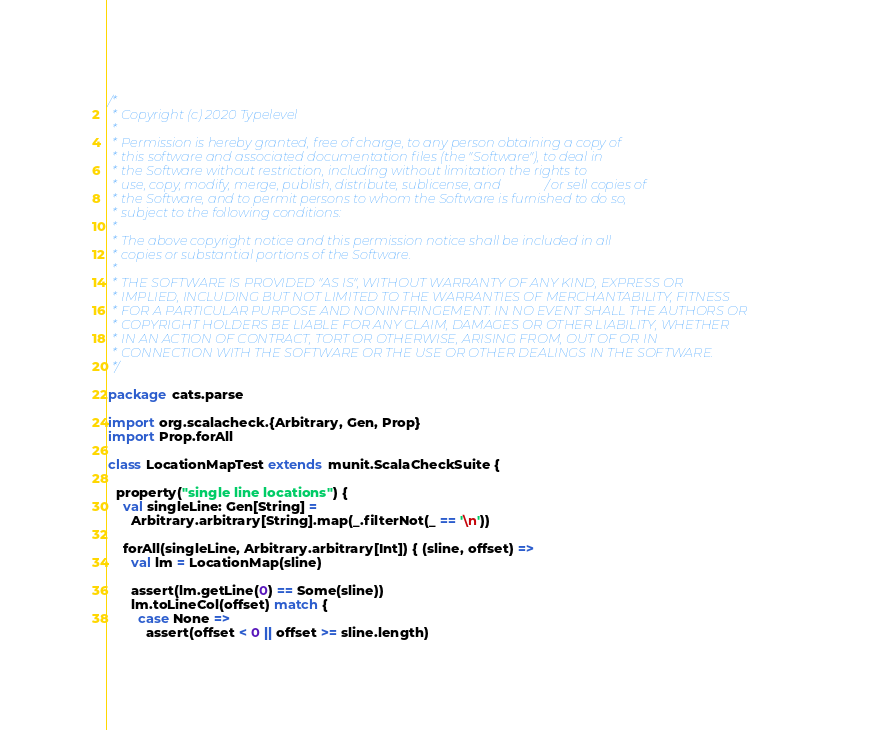<code> <loc_0><loc_0><loc_500><loc_500><_Scala_>/*
 * Copyright (c) 2020 Typelevel
 *
 * Permission is hereby granted, free of charge, to any person obtaining a copy of
 * this software and associated documentation files (the "Software"), to deal in
 * the Software without restriction, including without limitation the rights to
 * use, copy, modify, merge, publish, distribute, sublicense, and/or sell copies of
 * the Software, and to permit persons to whom the Software is furnished to do so,
 * subject to the following conditions:
 *
 * The above copyright notice and this permission notice shall be included in all
 * copies or substantial portions of the Software.
 *
 * THE SOFTWARE IS PROVIDED "AS IS", WITHOUT WARRANTY OF ANY KIND, EXPRESS OR
 * IMPLIED, INCLUDING BUT NOT LIMITED TO THE WARRANTIES OF MERCHANTABILITY, FITNESS
 * FOR A PARTICULAR PURPOSE AND NONINFRINGEMENT. IN NO EVENT SHALL THE AUTHORS OR
 * COPYRIGHT HOLDERS BE LIABLE FOR ANY CLAIM, DAMAGES OR OTHER LIABILITY, WHETHER
 * IN AN ACTION OF CONTRACT, TORT OR OTHERWISE, ARISING FROM, OUT OF OR IN
 * CONNECTION WITH THE SOFTWARE OR THE USE OR OTHER DEALINGS IN THE SOFTWARE.
 */

package cats.parse

import org.scalacheck.{Arbitrary, Gen, Prop}
import Prop.forAll

class LocationMapTest extends munit.ScalaCheckSuite {

  property("single line locations") {
    val singleLine: Gen[String] =
      Arbitrary.arbitrary[String].map(_.filterNot(_ == '\n'))

    forAll(singleLine, Arbitrary.arbitrary[Int]) { (sline, offset) =>
      val lm = LocationMap(sline)

      assert(lm.getLine(0) == Some(sline))
      lm.toLineCol(offset) match {
        case None =>
          assert(offset < 0 || offset >= sline.length)</code> 